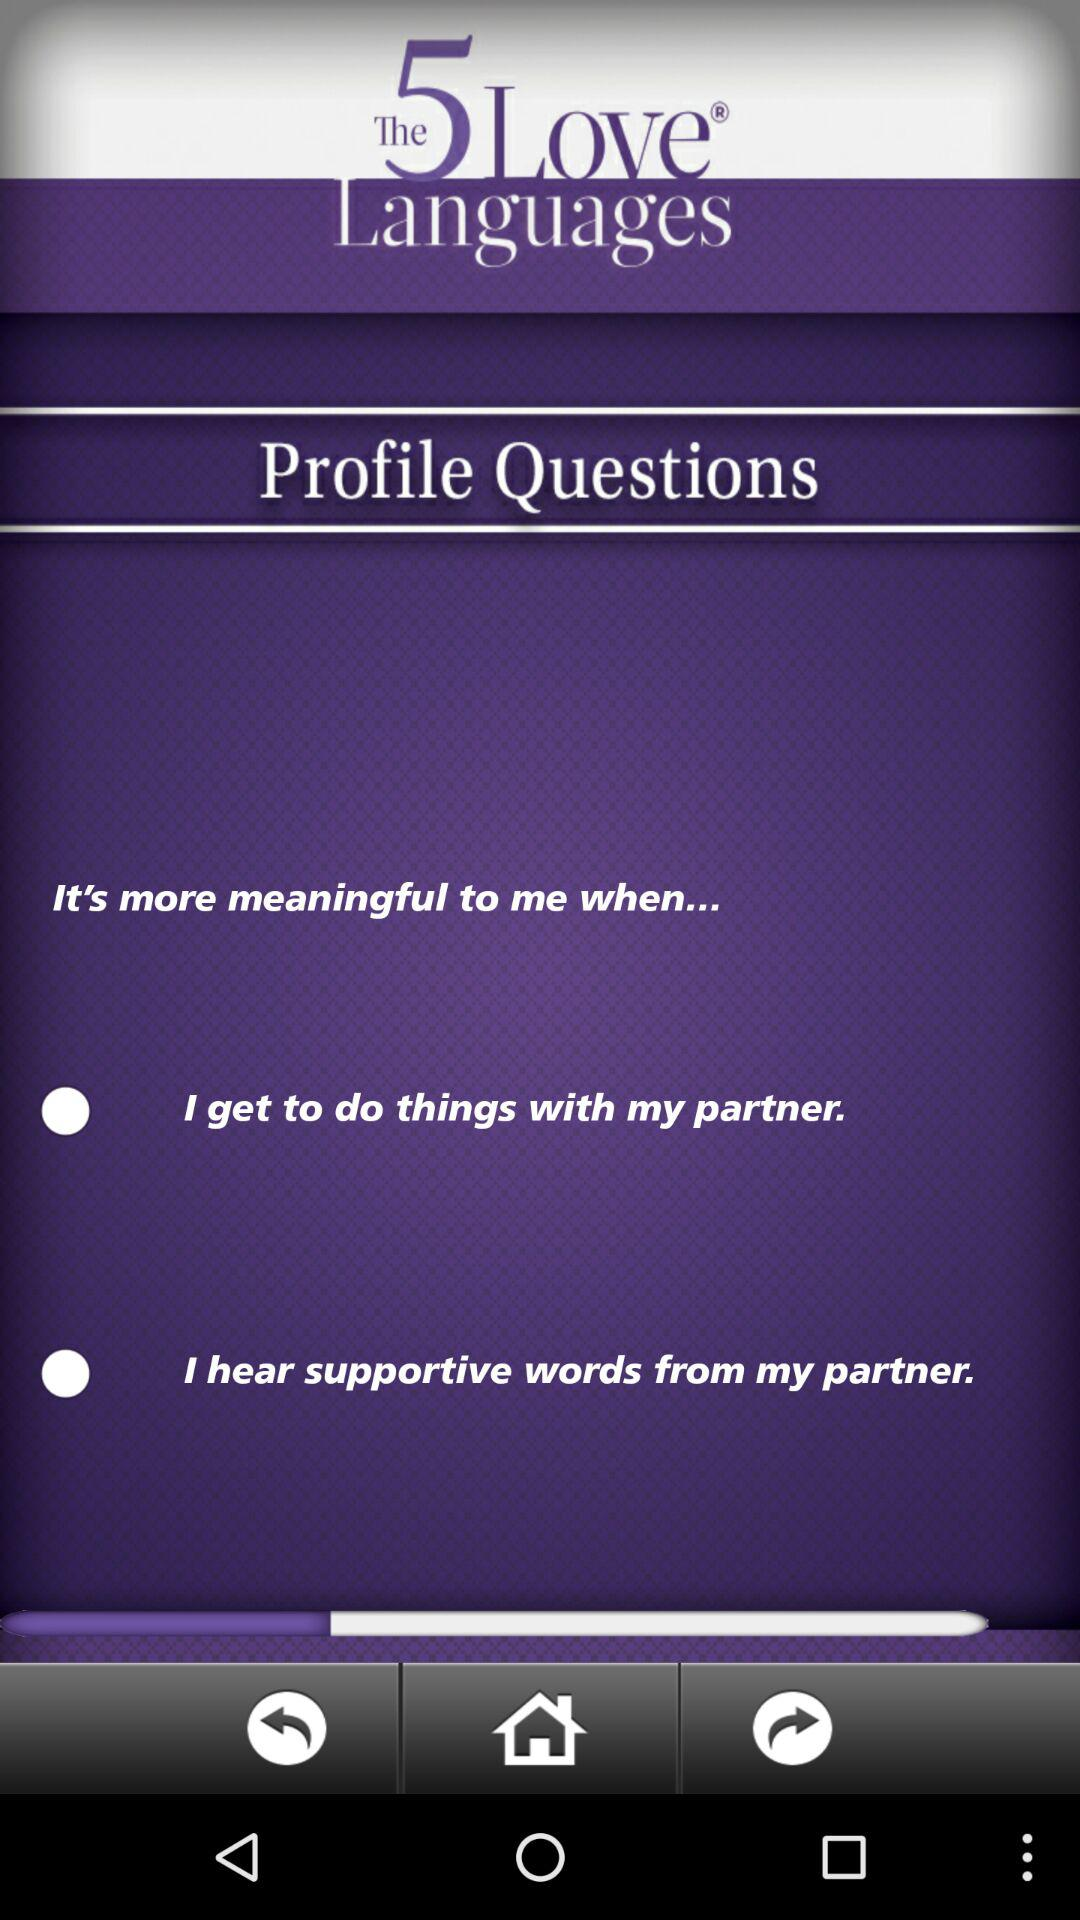Which option is selected?
When the provided information is insufficient, respond with <no answer>. <no answer> 